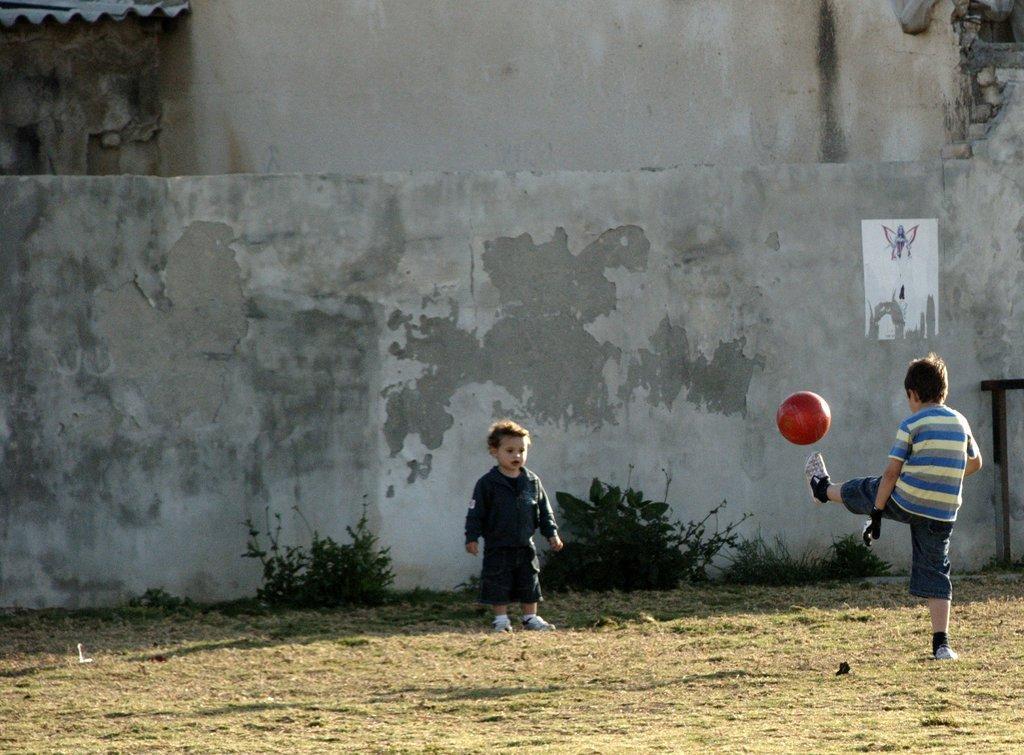Could you give a brief overview of what you see in this image? There is a boy standing on the right side and he is kicking a foot ball with his left leg. There is a boy standing in the center. There is a wall in the background. 